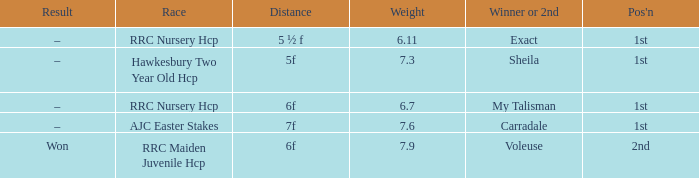3, and the end result was –? Carradale. 